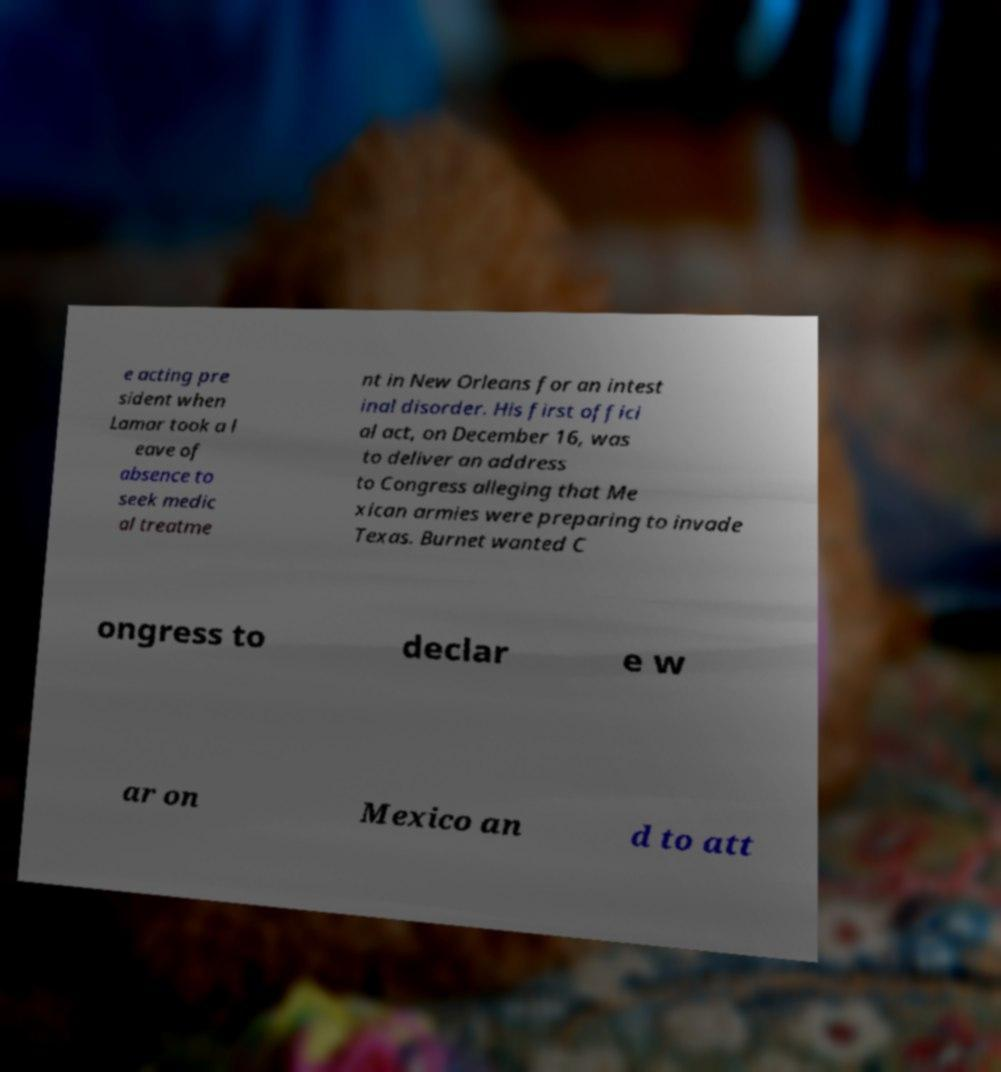Please read and relay the text visible in this image. What does it say? e acting pre sident when Lamar took a l eave of absence to seek medic al treatme nt in New Orleans for an intest inal disorder. His first offici al act, on December 16, was to deliver an address to Congress alleging that Me xican armies were preparing to invade Texas. Burnet wanted C ongress to declar e w ar on Mexico an d to att 